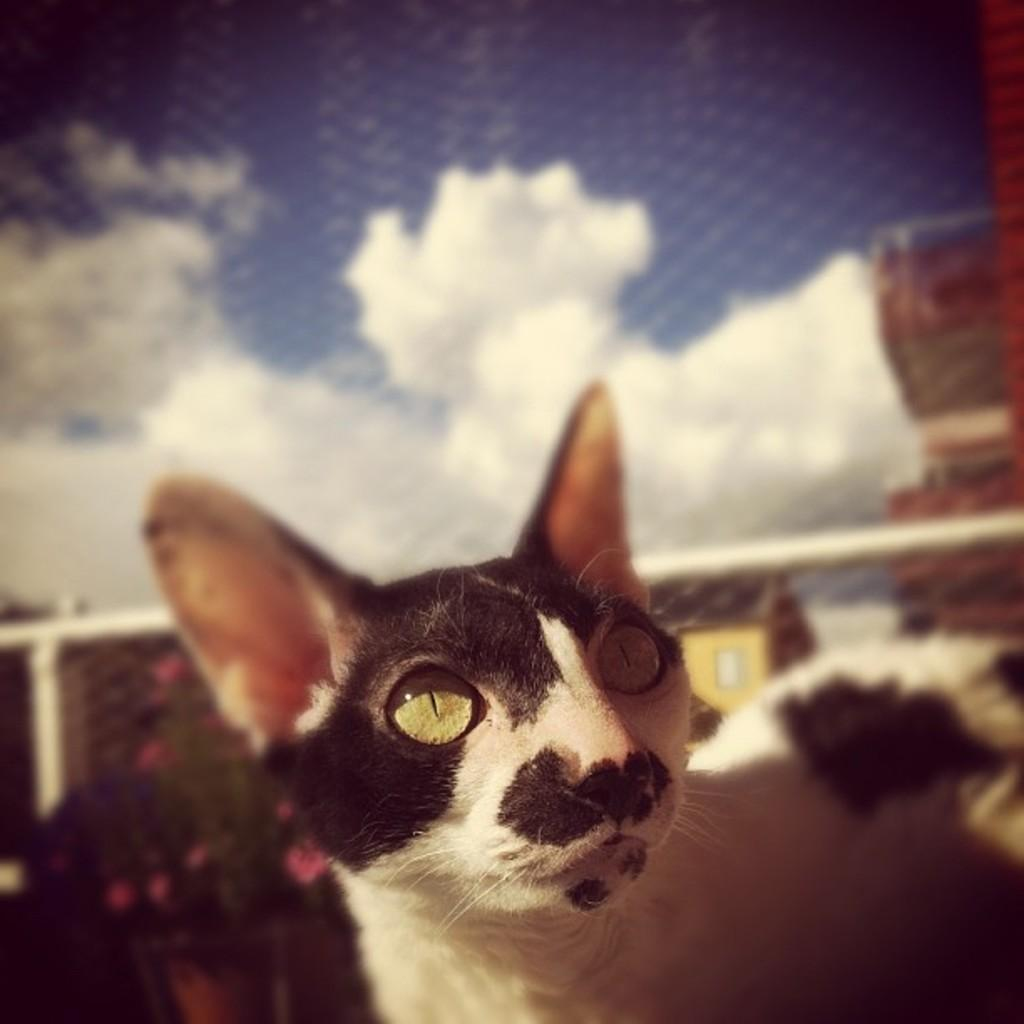What type of animal can be seen in the image? There is a black and white cat in the image. How would you describe the background of the image? The background has a blurred view. What material is visible in the image? Mesh is visible in the image. What else can be seen in the image? Rods are present in the image. What is the weather like in the image? The sky is cloudy in the image. What type of vegetation is present in the image? There are plants with flowers in the image. What type of structures are visible in the image? Houses are visible in the image. What is the weight of the group of people in the image? There are no people present in the image, so it is not possible to determine the weight of any group. 